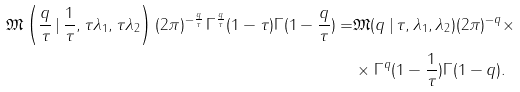Convert formula to latex. <formula><loc_0><loc_0><loc_500><loc_500>\mathfrak { M } \left ( \frac { q } { \tau } \, | \, \frac { 1 } { \tau } , \tau \lambda _ { 1 } , \tau \lambda _ { 2 } \right ) ( 2 \pi ) ^ { - \frac { q } { \tau } } \, \Gamma ^ { \frac { q } { \tau } } ( 1 - \tau ) \Gamma ( 1 - \frac { q } { \tau } ) = & \mathfrak { M } ( q \, | \, \tau , \lambda _ { 1 } , \lambda _ { 2 } ) ( 2 \pi ) ^ { - q } \times \\ & \times \Gamma ^ { q } ( 1 - \frac { 1 } { \tau } ) \Gamma ( 1 - q ) .</formula> 